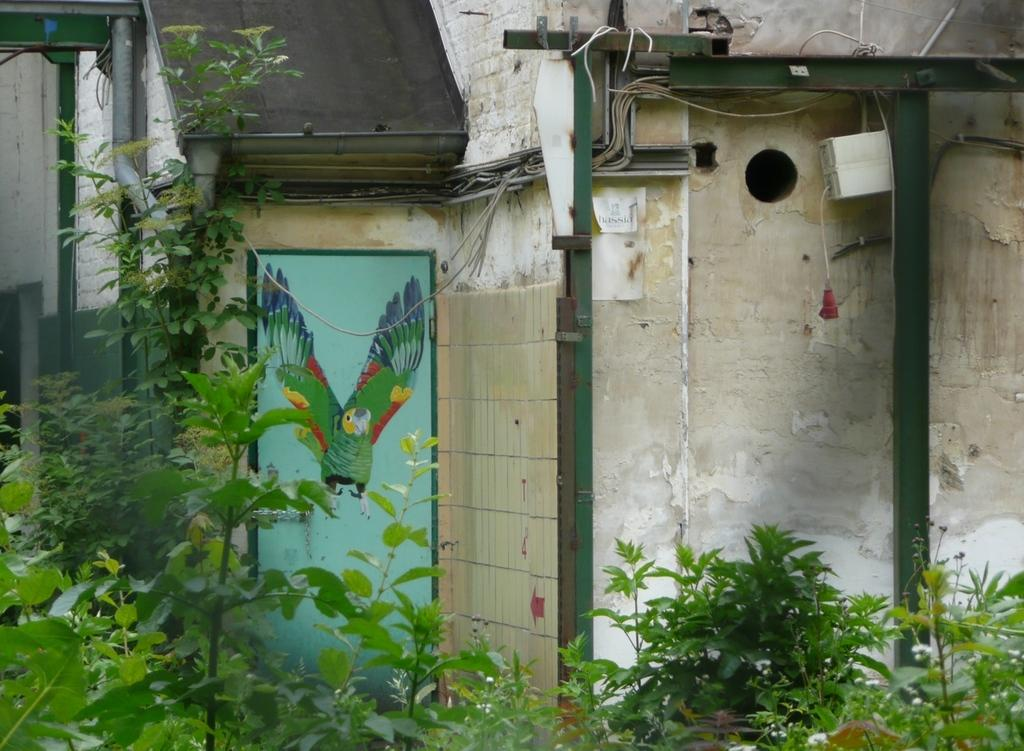What type of structures are located in the center of the image? There are houses in the center of the image. What can be seen attached to the poles in the image? There are wires in the image that are attached to the poles. What other objects can be seen in the image? There are pipes and a door in the image. What is on the door in the image? There is a painting on the door. What type of vegetation is in the foreground of the image? There are plants in the foreground of the image. How many lawyers are visible in the image? There are no lawyers present in the image. What type of frogs can be seen hopping around in the image? There are no frogs present in the image. 